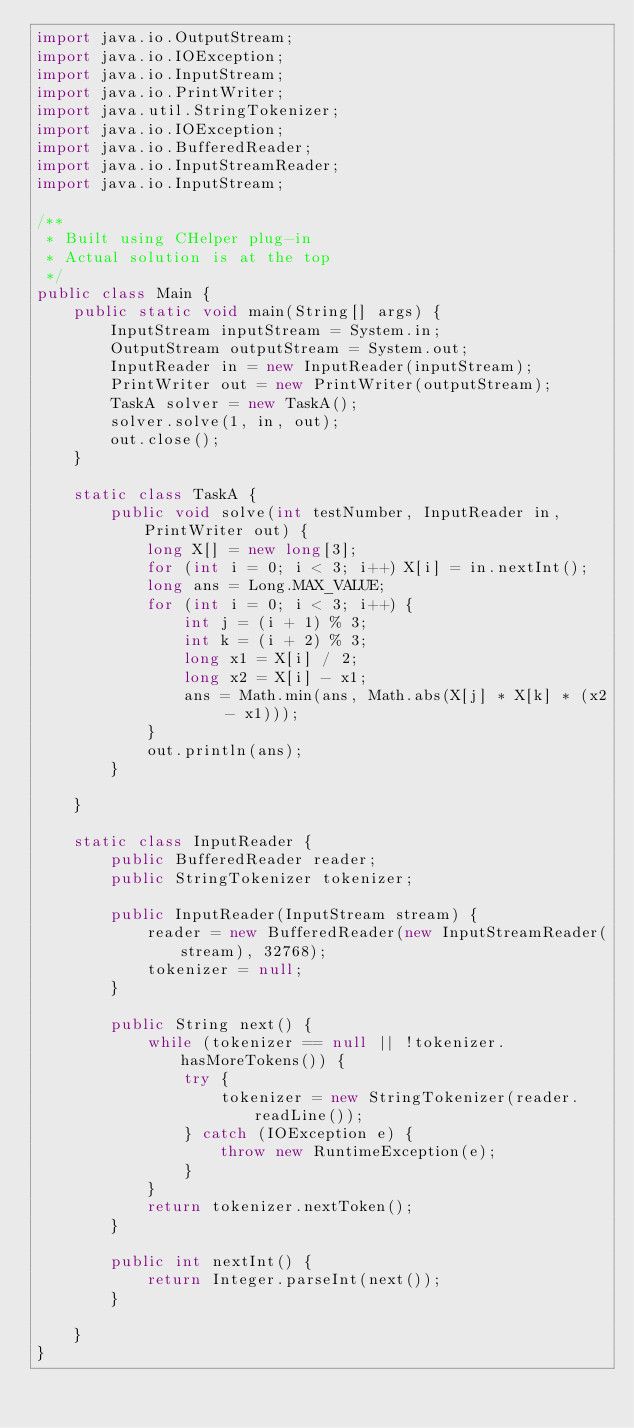Convert code to text. <code><loc_0><loc_0><loc_500><loc_500><_Java_>import java.io.OutputStream;
import java.io.IOException;
import java.io.InputStream;
import java.io.PrintWriter;
import java.util.StringTokenizer;
import java.io.IOException;
import java.io.BufferedReader;
import java.io.InputStreamReader;
import java.io.InputStream;

/**
 * Built using CHelper plug-in
 * Actual solution is at the top
 */
public class Main {
    public static void main(String[] args) {
        InputStream inputStream = System.in;
        OutputStream outputStream = System.out;
        InputReader in = new InputReader(inputStream);
        PrintWriter out = new PrintWriter(outputStream);
        TaskA solver = new TaskA();
        solver.solve(1, in, out);
        out.close();
    }

    static class TaskA {
        public void solve(int testNumber, InputReader in, PrintWriter out) {
            long X[] = new long[3];
            for (int i = 0; i < 3; i++) X[i] = in.nextInt();
            long ans = Long.MAX_VALUE;
            for (int i = 0; i < 3; i++) {
                int j = (i + 1) % 3;
                int k = (i + 2) % 3;
                long x1 = X[i] / 2;
                long x2 = X[i] - x1;
                ans = Math.min(ans, Math.abs(X[j] * X[k] * (x2 - x1)));
            }
            out.println(ans);
        }

    }

    static class InputReader {
        public BufferedReader reader;
        public StringTokenizer tokenizer;

        public InputReader(InputStream stream) {
            reader = new BufferedReader(new InputStreamReader(stream), 32768);
            tokenizer = null;
        }

        public String next() {
            while (tokenizer == null || !tokenizer.hasMoreTokens()) {
                try {
                    tokenizer = new StringTokenizer(reader.readLine());
                } catch (IOException e) {
                    throw new RuntimeException(e);
                }
            }
            return tokenizer.nextToken();
        }

        public int nextInt() {
            return Integer.parseInt(next());
        }

    }
}
</code> 